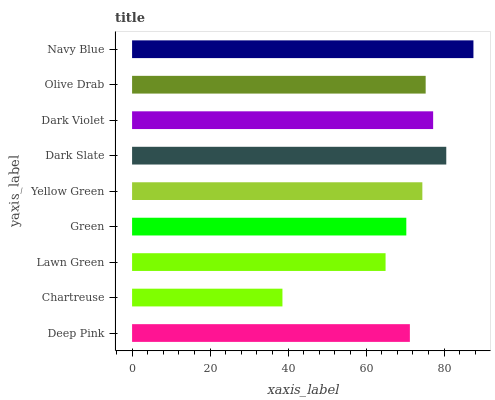Is Chartreuse the minimum?
Answer yes or no. Yes. Is Navy Blue the maximum?
Answer yes or no. Yes. Is Lawn Green the minimum?
Answer yes or no. No. Is Lawn Green the maximum?
Answer yes or no. No. Is Lawn Green greater than Chartreuse?
Answer yes or no. Yes. Is Chartreuse less than Lawn Green?
Answer yes or no. Yes. Is Chartreuse greater than Lawn Green?
Answer yes or no. No. Is Lawn Green less than Chartreuse?
Answer yes or no. No. Is Yellow Green the high median?
Answer yes or no. Yes. Is Yellow Green the low median?
Answer yes or no. Yes. Is Olive Drab the high median?
Answer yes or no. No. Is Lawn Green the low median?
Answer yes or no. No. 